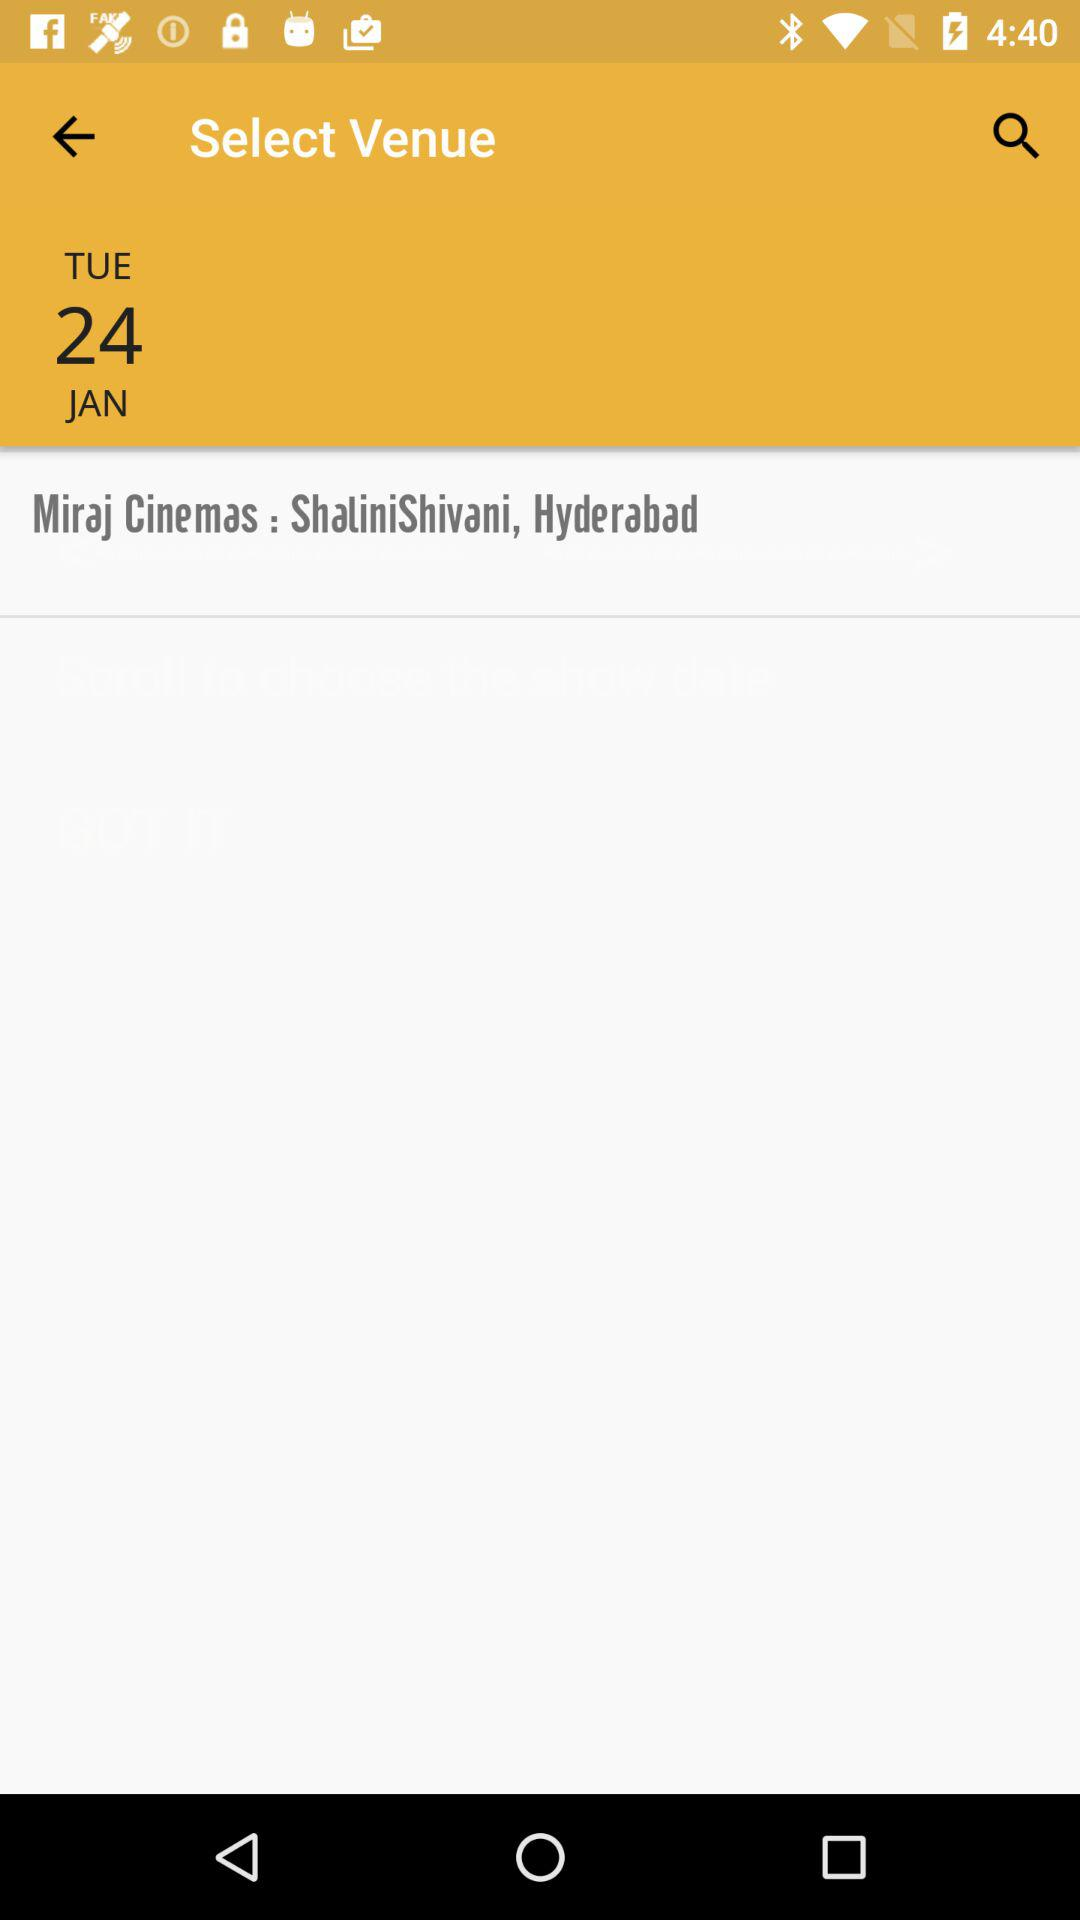What is the mentioned date? The mentioned date is Tuesday, January 24. 